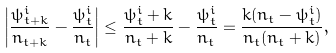Convert formula to latex. <formula><loc_0><loc_0><loc_500><loc_500>\left | \frac { \psi ^ { i } _ { t + k } } { n _ { t + k } } - \frac { \psi ^ { i } _ { t } } { n _ { t } } \right | \leq \frac { \psi ^ { i } _ { t } + k } { n _ { t } + k } - \frac { \psi ^ { i } _ { t } } { n _ { t } } = \frac { k ( n _ { t } - \psi ^ { i } _ { t } ) } { n _ { t } ( n _ { t } + k ) } ,</formula> 